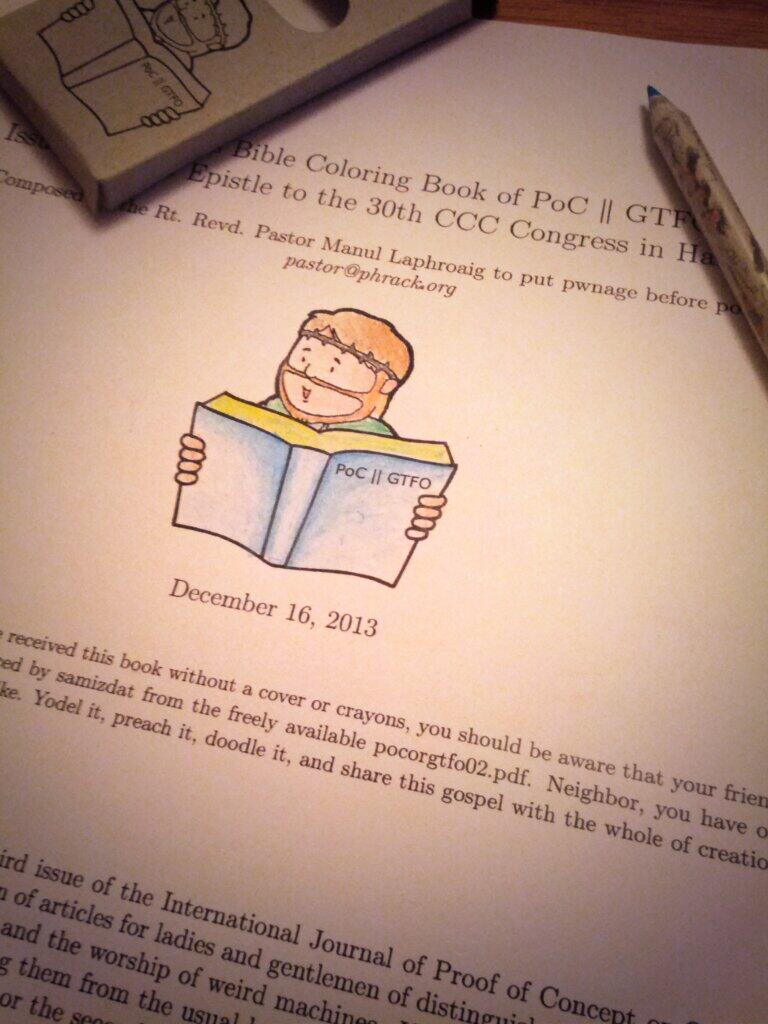<image>
Summarize the visual content of the image. A children's Bible Coloring Book of PoC GTFO 